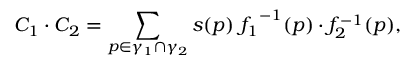<formula> <loc_0><loc_0><loc_500><loc_500>C _ { 1 } \cdot C _ { 2 } = \sum _ { p \in \gamma _ { 1 } \cap \gamma _ { 2 } } s ( p ) \, { f _ { 1 } } ^ { - 1 } ( p ) \cdot f _ { 2 } ^ { - 1 } ( p ) ,</formula> 